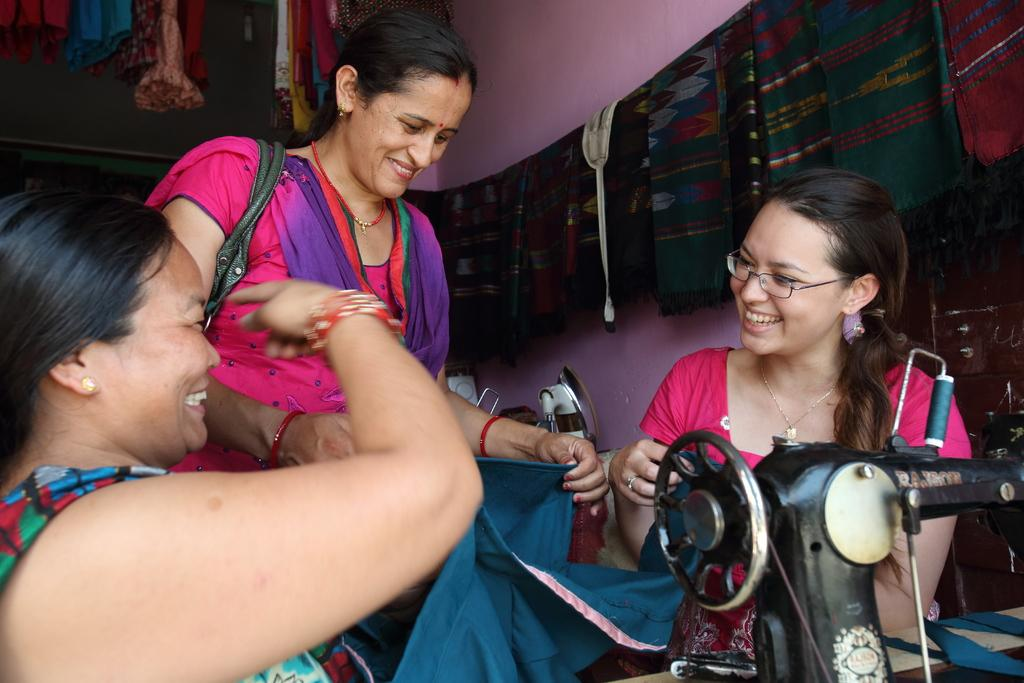How many ladies are present in the image? There are three ladies in the image. Can you describe the attire of one of the ladies? One of the ladies is wearing a bag. What object related to textiles can be seen in the image? There is a sewing machine in the image. What can be seen hanging in the background of the image? Clothes are hanging on a rope in the background. What type of legal advice is the lady in the middle providing in the image? There is no indication in the image that any of the ladies are providing legal advice, as they are not depicted in a professional setting or wearing any legal attire. --- Facts: 1. There is a car in the image. 2. The car is parked on the street. 3. There are trees on both sides of the street. 4. The sky is visible in the image. Absurd Topics: parrot, sand, volcano Conversation: What is the main subject of the image? The main subject of the image is a car. Where is the car located in the image? The car is parked on the street. What can be seen on both sides of the street in the image? There are trees on both sides of the street. What is visible in the background of the image? The sky is visible in the image. Reasoning: Let's think step by step in order to produce the conversation. We start by identifying the main subject of the image, which is the car. Then, we describe the location of the car, noting that it is parked on the street. Next, we mention the presence of trees on both sides of the street, which provides context for the setting. Finally, we describe the background of the image, noting that the sky is visible. Absurd Question/Answer: Can you tell me how many parrots are sitting on the car in the image? There are no parrots present in the image; the car is parked on the street with no animals visible. --- Facts: 1. There is a person holding a camera in the image. 2. The person is standing on a bridge. 3. There is a river flowing under the bridge. 4. Mountains can be seen in the background. Absurd Topics: elephant, piano, rainbow Conversation: What is the person in the image holding? The person in the image is holding a camera. Where is the person standing in the image? The person is standing on a bridge. What can be seen flowing under the bridge in the image? There is a river flowing under the bridge. What is visible in the background of the image? Mountains can be seen in the background. Reasoning: Let's think step by step in order to produce the conversation. 